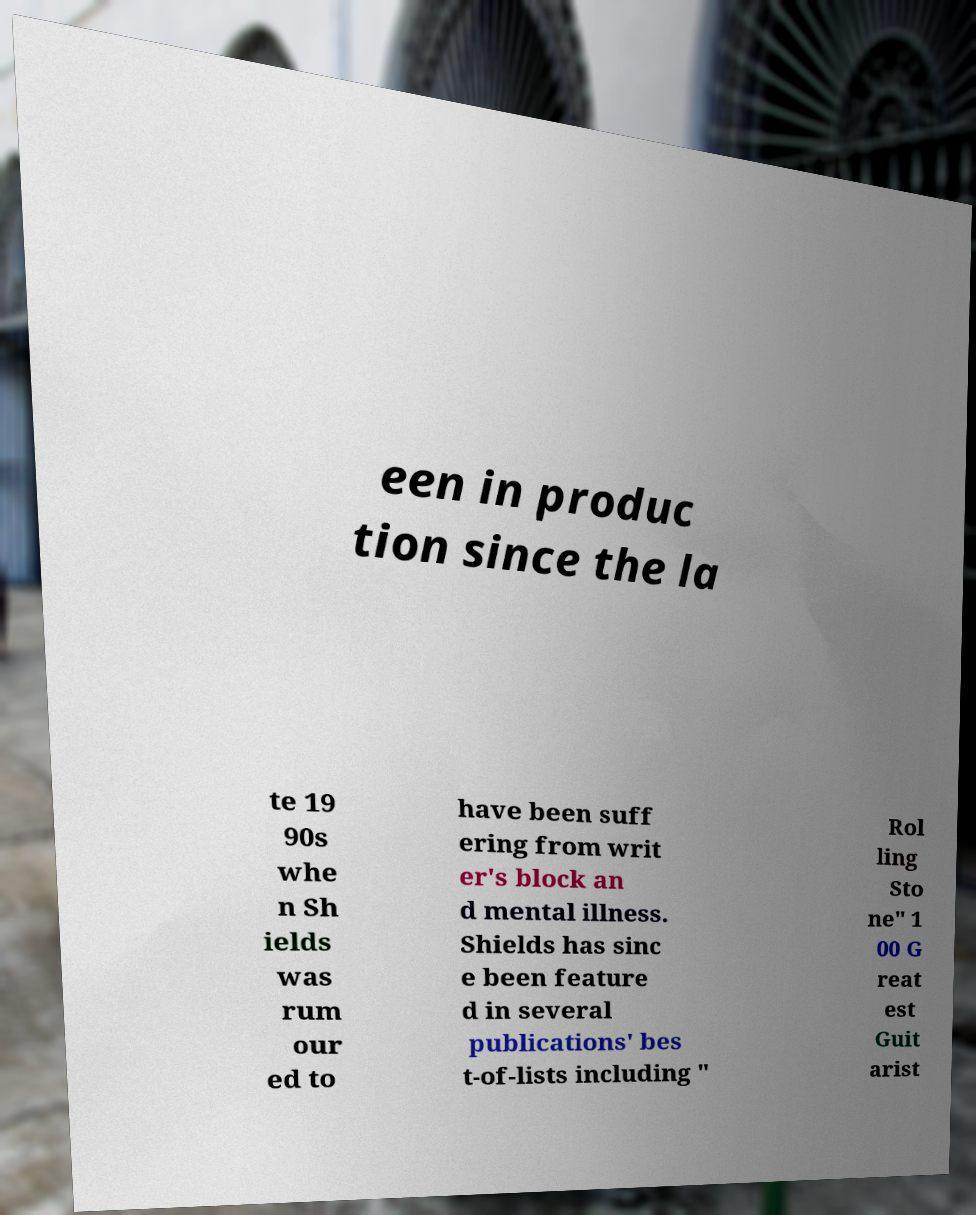Could you assist in decoding the text presented in this image and type it out clearly? een in produc tion since the la te 19 90s whe n Sh ields was rum our ed to have been suff ering from writ er's block an d mental illness. Shields has sinc e been feature d in several publications' bes t-of-lists including " Rol ling Sto ne" 1 00 G reat est Guit arist 